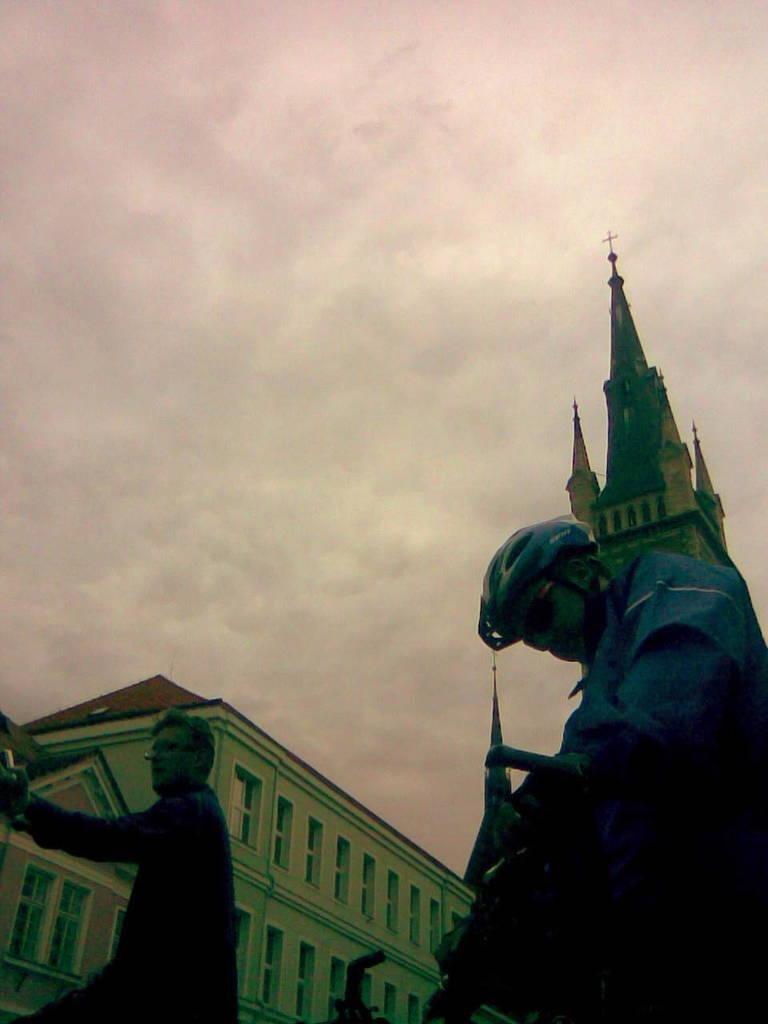What is visible at the top of the image? The sky is visible at the top of the image. What structure can be seen at the bottom of the image? There is a building at the bottom of the image. How many people are the number of persons in the image? There are two persons in the image. What is one of the persons wearing? One of the persons is wearing a helmet. Can you see a cat playing with an icicle in the image? There is no cat or icicle present in the image. 